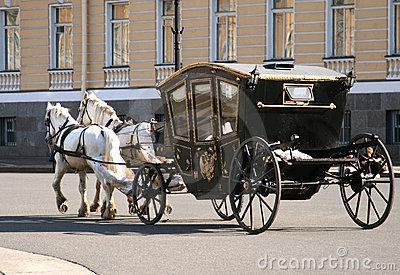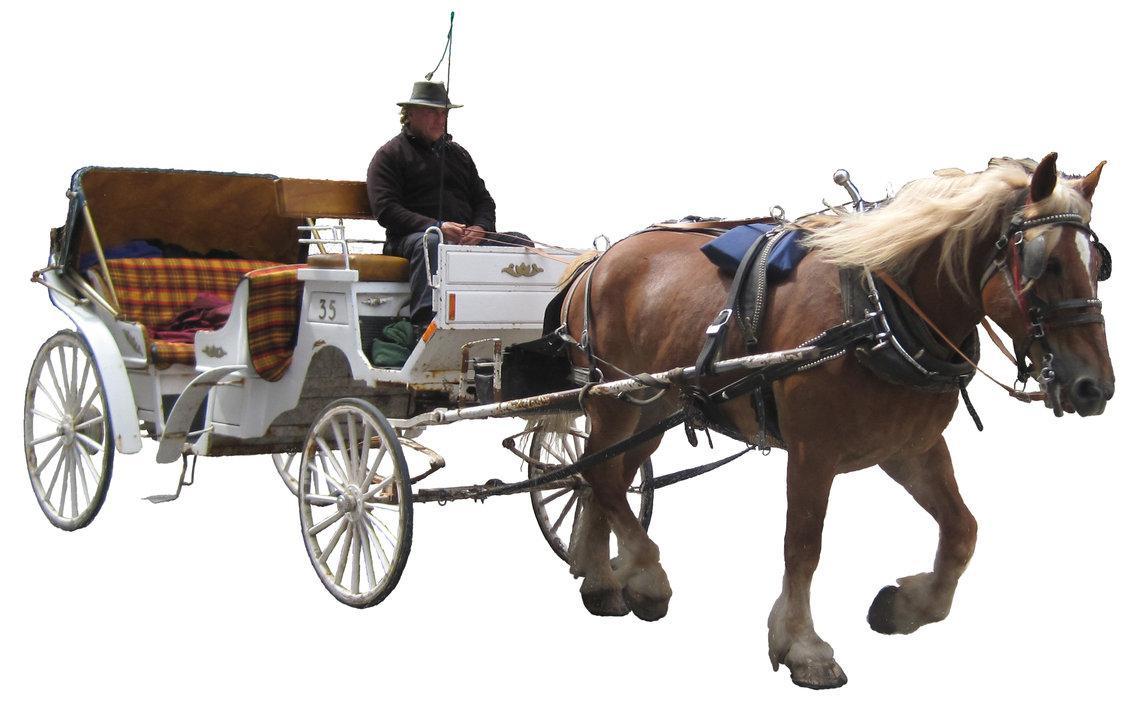The first image is the image on the left, the second image is the image on the right. Considering the images on both sides, is "The horse drawn carriage in the image on the right is against a plain white background." valid? Answer yes or no. Yes. The first image is the image on the left, the second image is the image on the right. For the images shown, is this caption "There is a carriage hitched to a pair of white horses." true? Answer yes or no. Yes. 